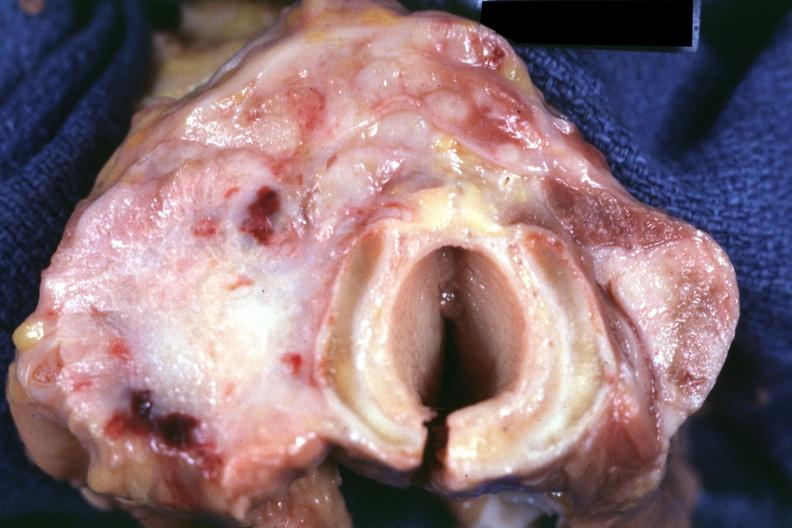does this section show section through thyroid and trachea apparently?
Answer the question using a single word or phrase. No 